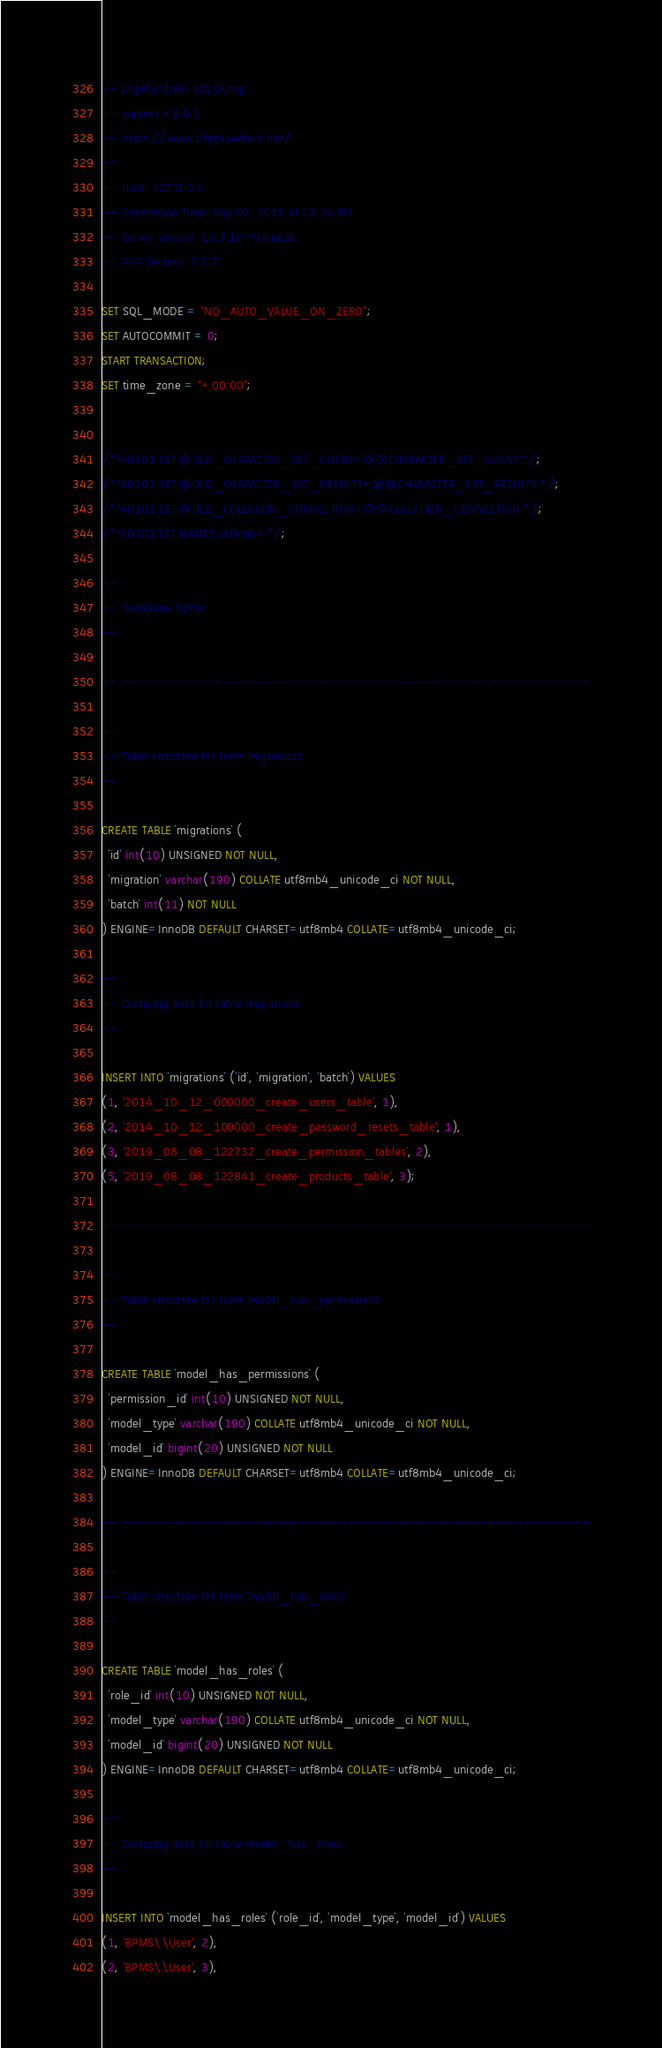<code> <loc_0><loc_0><loc_500><loc_500><_SQL_>-- phpMyAdmin SQL Dump
-- version 4.9.0.1
-- https://www.phpmyadmin.net/
--
-- Host: 127.0.0.1
-- Generation Time: Aug 09, 2019 at 12:24 PM
-- Server version: 10.3.16-MariaDB
-- PHP Version: 7.3.7

SET SQL_MODE = "NO_AUTO_VALUE_ON_ZERO";
SET AUTOCOMMIT = 0;
START TRANSACTION;
SET time_zone = "+00:00";


/*!40101 SET @OLD_CHARACTER_SET_CLIENT=@@CHARACTER_SET_CLIENT */;
/*!40101 SET @OLD_CHARACTER_SET_RESULTS=@@CHARACTER_SET_RESULTS */;
/*!40101 SET @OLD_COLLATION_CONNECTION=@@COLLATION_CONNECTION */;
/*!40101 SET NAMES utf8mb4 */;

--
-- Database: `bpms`
--

-- --------------------------------------------------------

--
-- Table structure for table `migrations`
--

CREATE TABLE `migrations` (
  `id` int(10) UNSIGNED NOT NULL,
  `migration` varchar(190) COLLATE utf8mb4_unicode_ci NOT NULL,
  `batch` int(11) NOT NULL
) ENGINE=InnoDB DEFAULT CHARSET=utf8mb4 COLLATE=utf8mb4_unicode_ci;

--
-- Dumping data for table `migrations`
--

INSERT INTO `migrations` (`id`, `migration`, `batch`) VALUES
(1, '2014_10_12_000000_create_users_table', 1),
(2, '2014_10_12_100000_create_password_resets_table', 1),
(3, '2019_08_08_122732_create_permission_tables', 2),
(5, '2019_08_08_122841_create_products_table', 3);

-- --------------------------------------------------------

--
-- Table structure for table `model_has_permissions`
--

CREATE TABLE `model_has_permissions` (
  `permission_id` int(10) UNSIGNED NOT NULL,
  `model_type` varchar(190) COLLATE utf8mb4_unicode_ci NOT NULL,
  `model_id` bigint(20) UNSIGNED NOT NULL
) ENGINE=InnoDB DEFAULT CHARSET=utf8mb4 COLLATE=utf8mb4_unicode_ci;

-- --------------------------------------------------------

--
-- Table structure for table `model_has_roles`
--

CREATE TABLE `model_has_roles` (
  `role_id` int(10) UNSIGNED NOT NULL,
  `model_type` varchar(190) COLLATE utf8mb4_unicode_ci NOT NULL,
  `model_id` bigint(20) UNSIGNED NOT NULL
) ENGINE=InnoDB DEFAULT CHARSET=utf8mb4 COLLATE=utf8mb4_unicode_ci;

--
-- Dumping data for table `model_has_roles`
--

INSERT INTO `model_has_roles` (`role_id`, `model_type`, `model_id`) VALUES
(1, 'BPMS\\User', 2),
(2, 'BPMS\\User', 3),</code> 